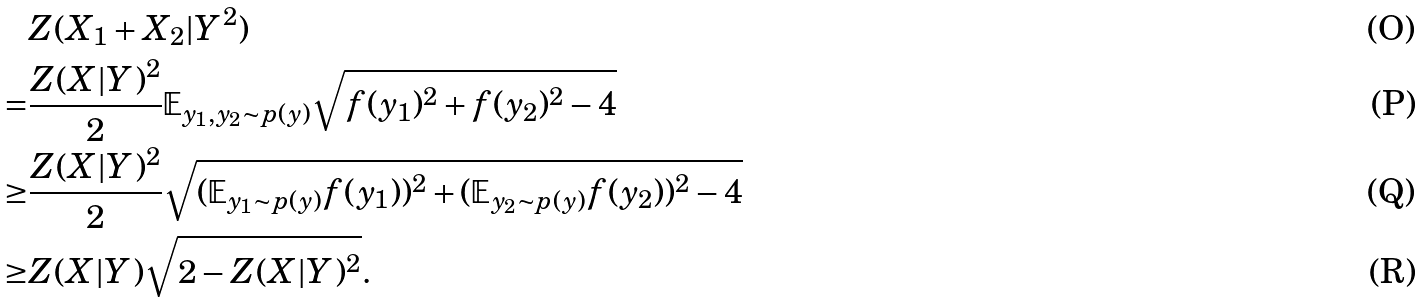Convert formula to latex. <formula><loc_0><loc_0><loc_500><loc_500>& Z ( X _ { 1 } + X _ { 2 } | Y ^ { 2 } ) \\ = & \frac { Z ( X | Y ) ^ { 2 } } { 2 } \mathbb { E } _ { y _ { 1 } , y _ { 2 } \sim p ( y ) } \sqrt { f ( y _ { 1 } ) ^ { 2 } + f ( y _ { 2 } ) ^ { 2 } - 4 } \\ \geq & \frac { Z ( X | Y ) ^ { 2 } } { 2 } \sqrt { ( \mathbb { E } _ { y _ { 1 } \sim p ( y ) } f ( y _ { 1 } ) ) ^ { 2 } + ( \mathbb { E } _ { y _ { 2 } \sim p ( y ) } f ( y _ { 2 } ) ) ^ { 2 } - 4 } \\ \geq & Z ( X | Y ) \sqrt { 2 - Z ( X | Y ) ^ { 2 } } .</formula> 